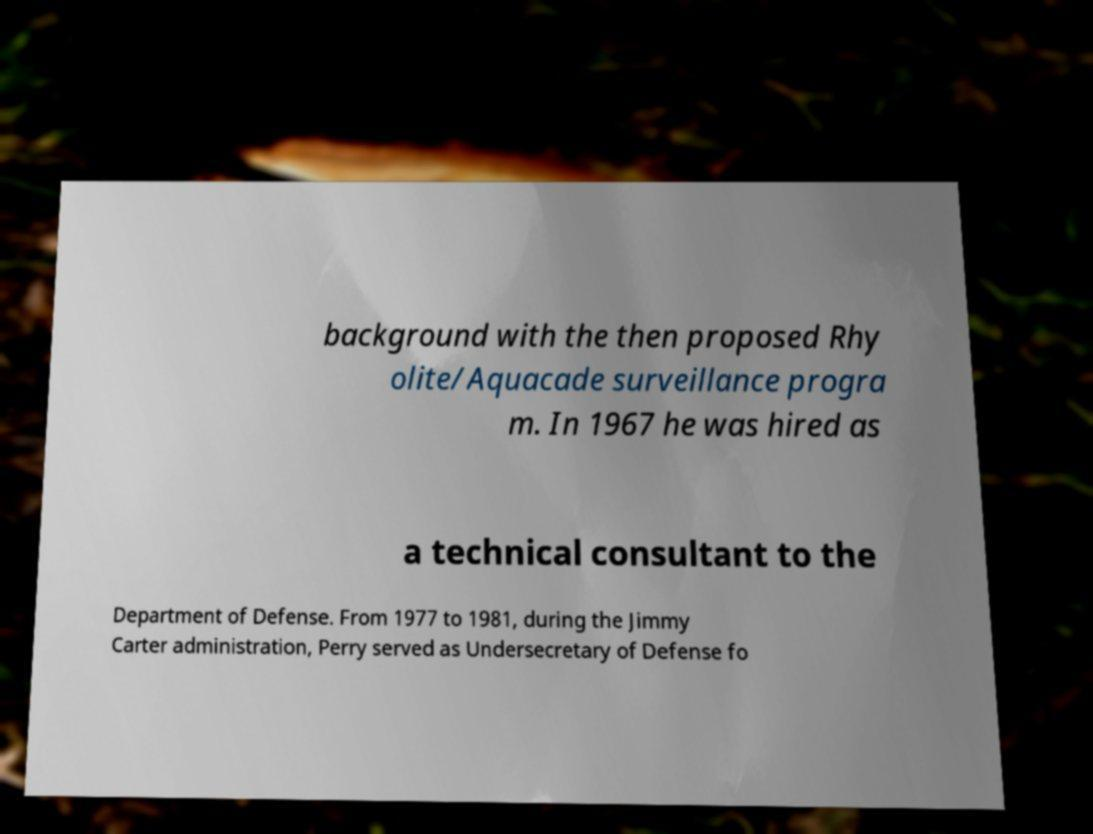There's text embedded in this image that I need extracted. Can you transcribe it verbatim? background with the then proposed Rhy olite/Aquacade surveillance progra m. In 1967 he was hired as a technical consultant to the Department of Defense. From 1977 to 1981, during the Jimmy Carter administration, Perry served as Undersecretary of Defense fo 